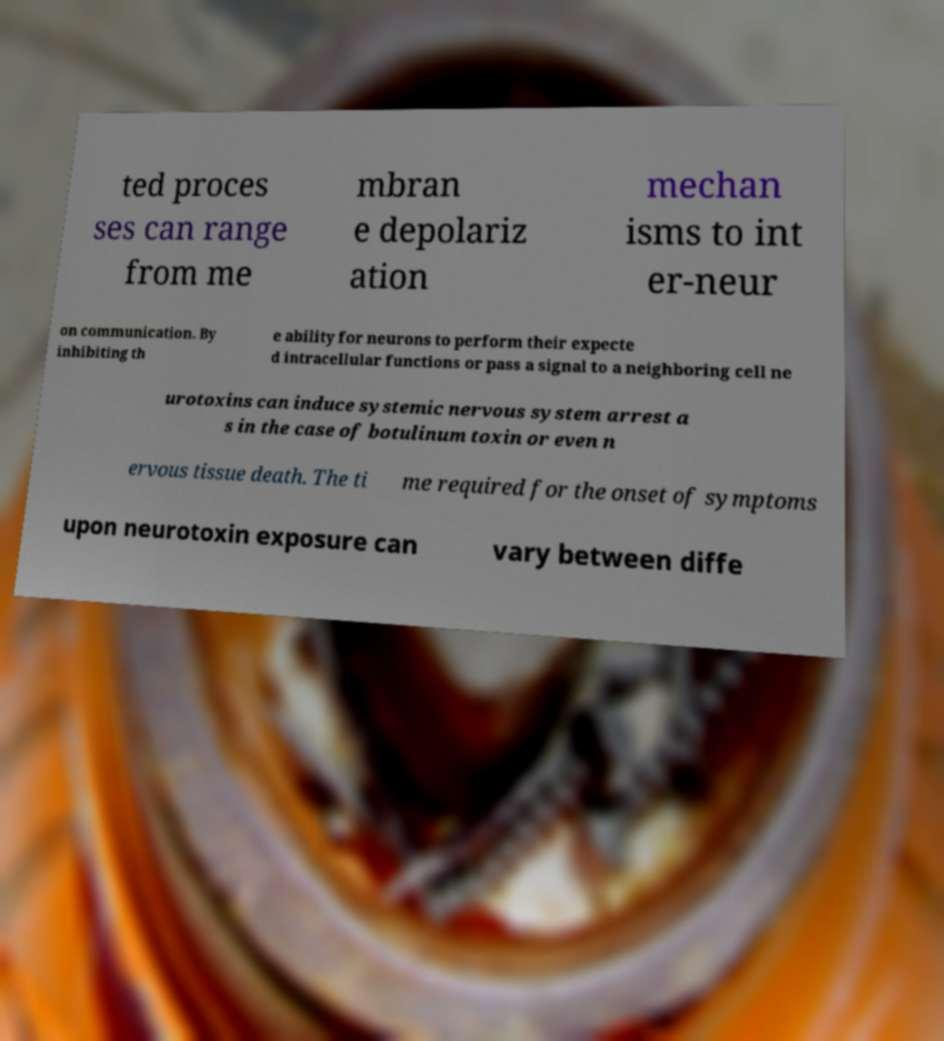What messages or text are displayed in this image? I need them in a readable, typed format. ted proces ses can range from me mbran e depolariz ation mechan isms to int er-neur on communication. By inhibiting th e ability for neurons to perform their expecte d intracellular functions or pass a signal to a neighboring cell ne urotoxins can induce systemic nervous system arrest a s in the case of botulinum toxin or even n ervous tissue death. The ti me required for the onset of symptoms upon neurotoxin exposure can vary between diffe 